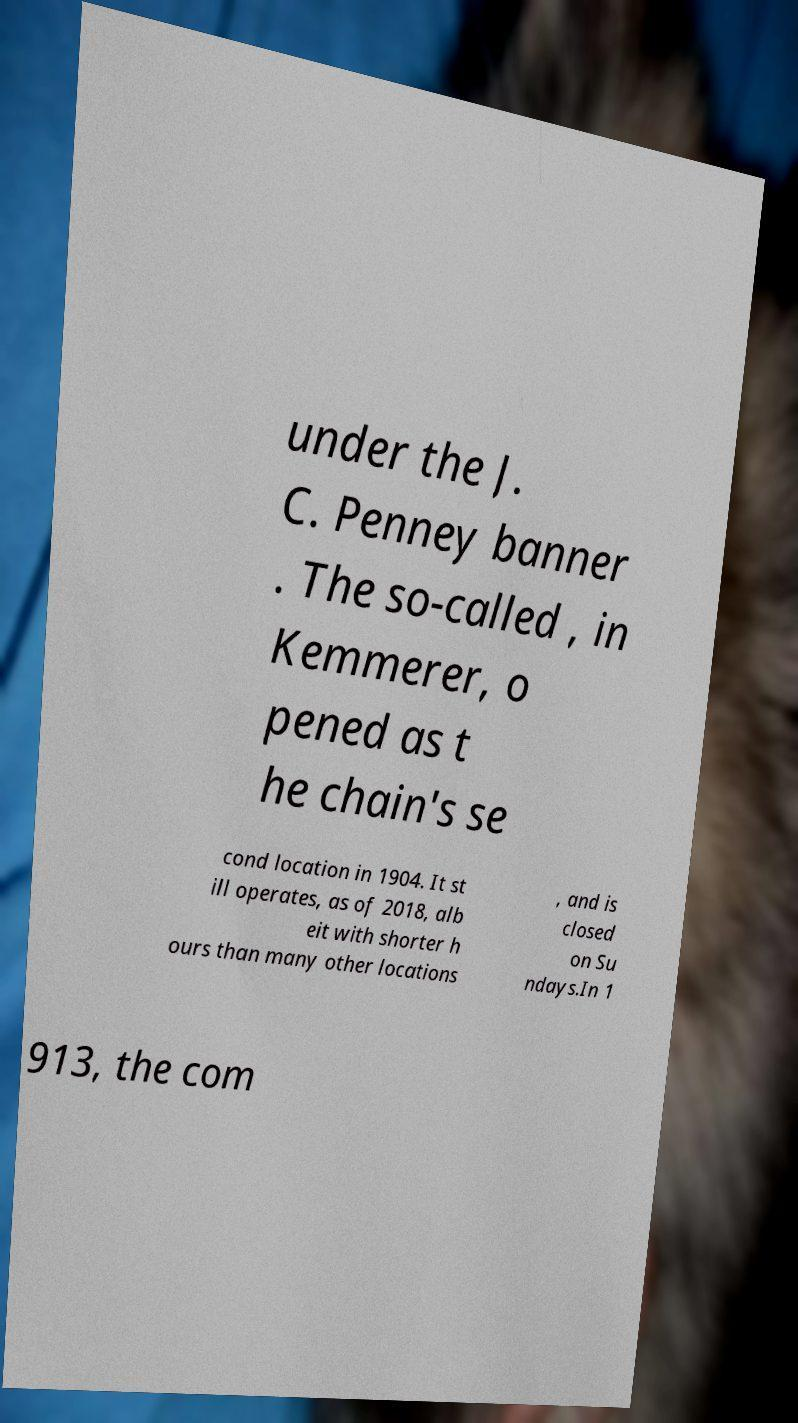Can you read and provide the text displayed in the image?This photo seems to have some interesting text. Can you extract and type it out for me? under the J. C. Penney banner . The so-called , in Kemmerer, o pened as t he chain's se cond location in 1904. It st ill operates, as of 2018, alb eit with shorter h ours than many other locations , and is closed on Su ndays.In 1 913, the com 